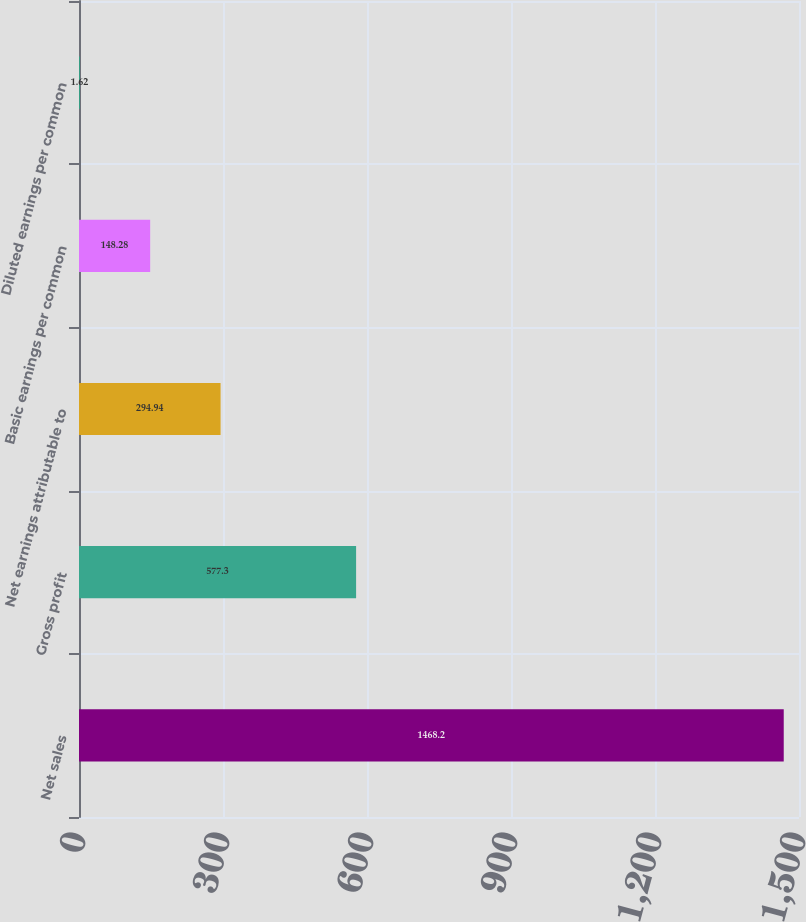<chart> <loc_0><loc_0><loc_500><loc_500><bar_chart><fcel>Net sales<fcel>Gross profit<fcel>Net earnings attributable to<fcel>Basic earnings per common<fcel>Diluted earnings per common<nl><fcel>1468.2<fcel>577.3<fcel>294.94<fcel>148.28<fcel>1.62<nl></chart> 